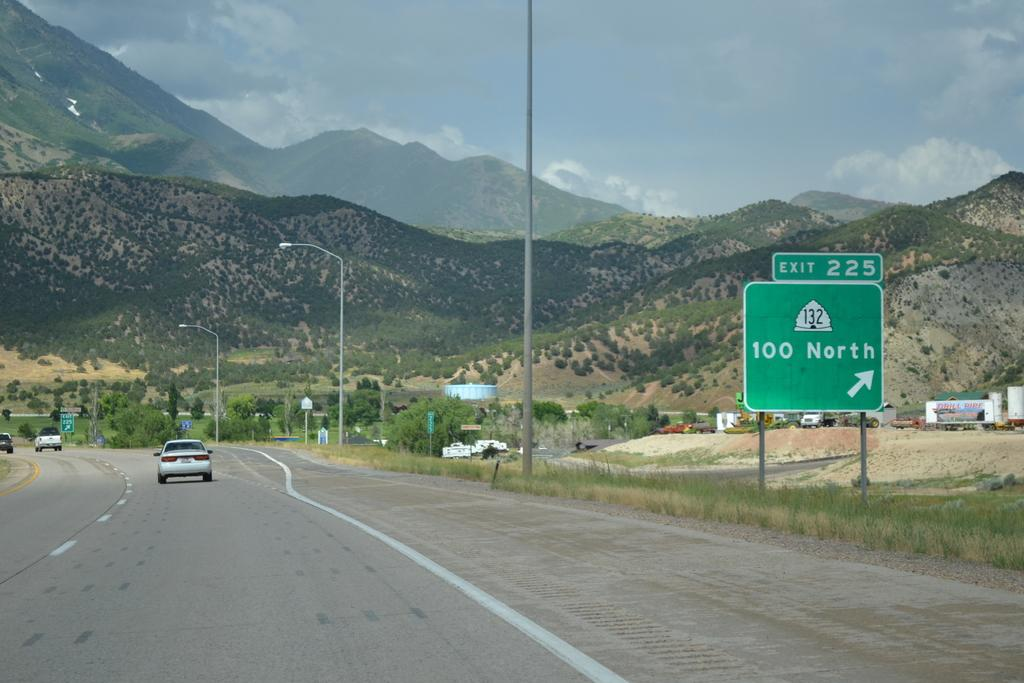Provide a one-sentence caption for the provided image. a road with a sign that says 100 north on it. 